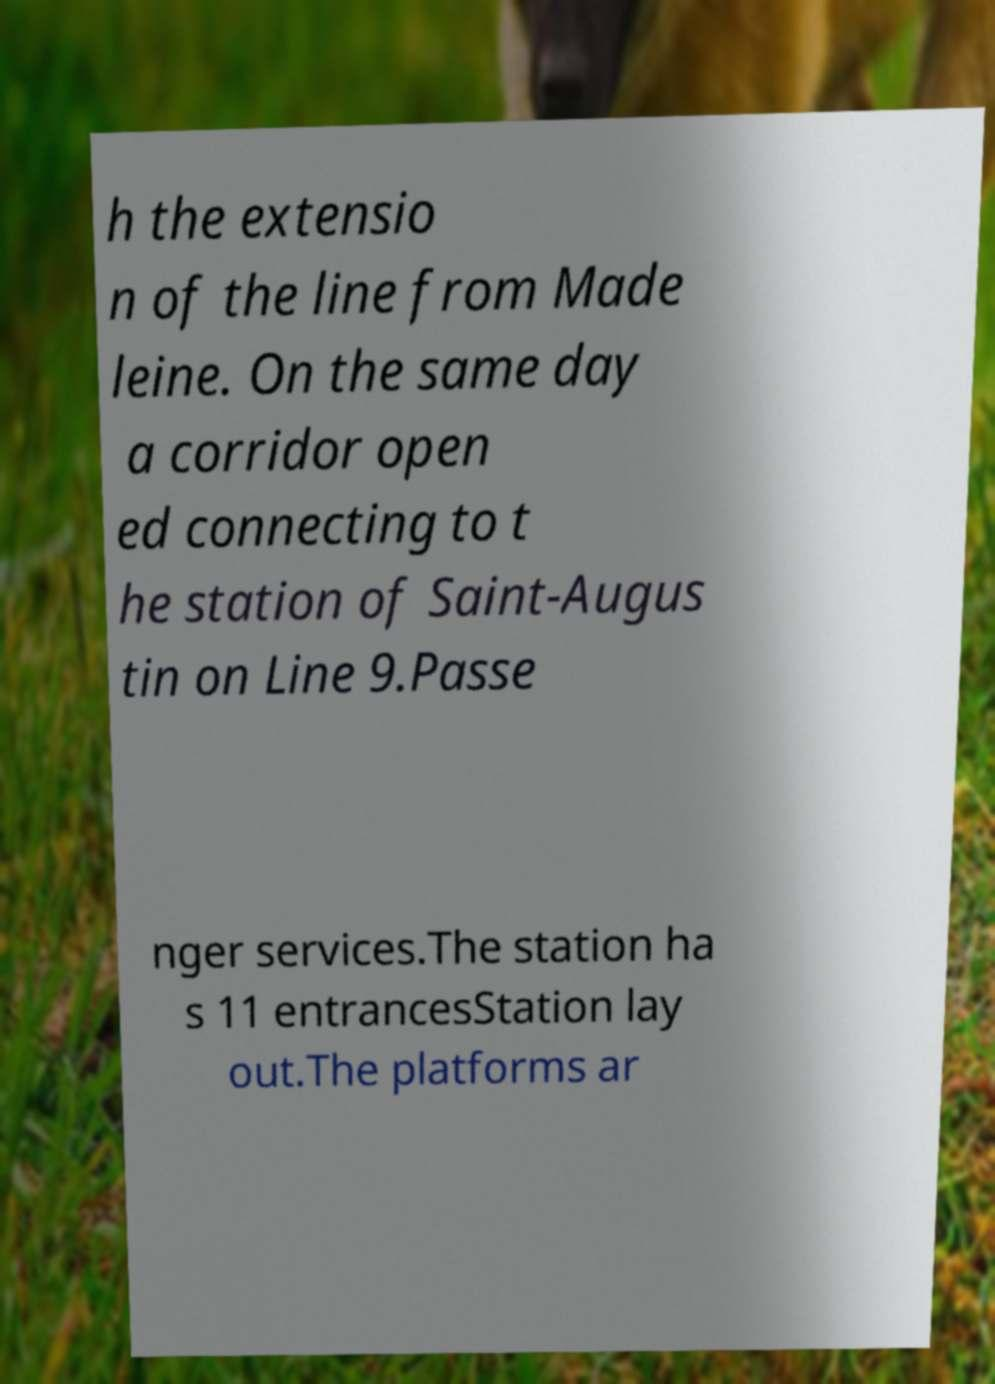Could you extract and type out the text from this image? h the extensio n of the line from Made leine. On the same day a corridor open ed connecting to t he station of Saint-Augus tin on Line 9.Passe nger services.The station ha s 11 entrancesStation lay out.The platforms ar 